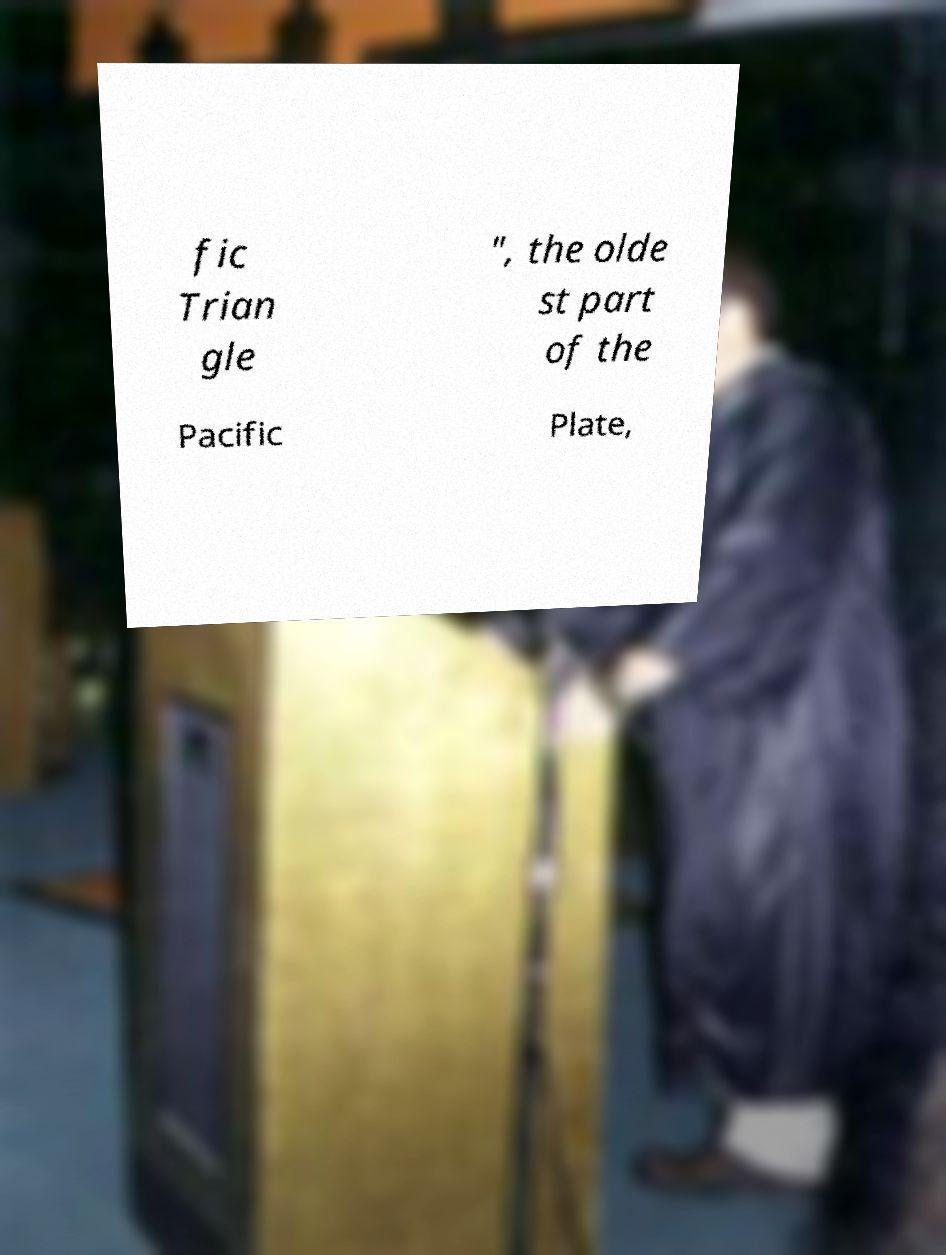What messages or text are displayed in this image? I need them in a readable, typed format. fic Trian gle ", the olde st part of the Pacific Plate, 